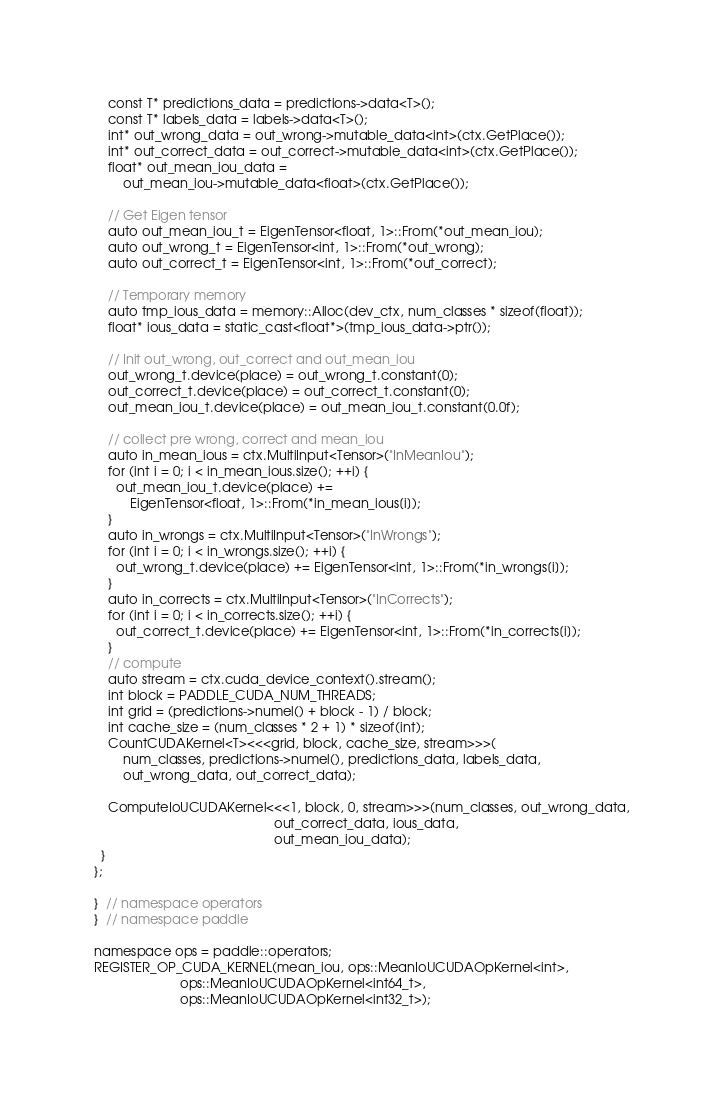<code> <loc_0><loc_0><loc_500><loc_500><_Cuda_>    const T* predictions_data = predictions->data<T>();
    const T* labels_data = labels->data<T>();
    int* out_wrong_data = out_wrong->mutable_data<int>(ctx.GetPlace());
    int* out_correct_data = out_correct->mutable_data<int>(ctx.GetPlace());
    float* out_mean_iou_data =
        out_mean_iou->mutable_data<float>(ctx.GetPlace());

    // Get Eigen tensor
    auto out_mean_iou_t = EigenTensor<float, 1>::From(*out_mean_iou);
    auto out_wrong_t = EigenTensor<int, 1>::From(*out_wrong);
    auto out_correct_t = EigenTensor<int, 1>::From(*out_correct);

    // Temporary memory
    auto tmp_ious_data = memory::Alloc(dev_ctx, num_classes * sizeof(float));
    float* ious_data = static_cast<float*>(tmp_ious_data->ptr());

    // Init out_wrong, out_correct and out_mean_iou
    out_wrong_t.device(place) = out_wrong_t.constant(0);
    out_correct_t.device(place) = out_correct_t.constant(0);
    out_mean_iou_t.device(place) = out_mean_iou_t.constant(0.0f);

    // collect pre wrong, correct and mean_iou
    auto in_mean_ious = ctx.MultiInput<Tensor>("InMeanIou");
    for (int i = 0; i < in_mean_ious.size(); ++i) {
      out_mean_iou_t.device(place) +=
          EigenTensor<float, 1>::From(*in_mean_ious[i]);
    }
    auto in_wrongs = ctx.MultiInput<Tensor>("InWrongs");
    for (int i = 0; i < in_wrongs.size(); ++i) {
      out_wrong_t.device(place) += EigenTensor<int, 1>::From(*in_wrongs[i]);
    }
    auto in_corrects = ctx.MultiInput<Tensor>("InCorrects");
    for (int i = 0; i < in_corrects.size(); ++i) {
      out_correct_t.device(place) += EigenTensor<int, 1>::From(*in_corrects[i]);
    }
    // compute
    auto stream = ctx.cuda_device_context().stream();
    int block = PADDLE_CUDA_NUM_THREADS;
    int grid = (predictions->numel() + block - 1) / block;
    int cache_size = (num_classes * 2 + 1) * sizeof(int);
    CountCUDAKernel<T><<<grid, block, cache_size, stream>>>(
        num_classes, predictions->numel(), predictions_data, labels_data,
        out_wrong_data, out_correct_data);

    ComputeIoUCUDAKernel<<<1, block, 0, stream>>>(num_classes, out_wrong_data,
                                                  out_correct_data, ious_data,
                                                  out_mean_iou_data);
  }
};

}  // namespace operators
}  // namespace paddle

namespace ops = paddle::operators;
REGISTER_OP_CUDA_KERNEL(mean_iou, ops::MeanIoUCUDAOpKernel<int>,
                        ops::MeanIoUCUDAOpKernel<int64_t>,
                        ops::MeanIoUCUDAOpKernel<int32_t>);
</code> 